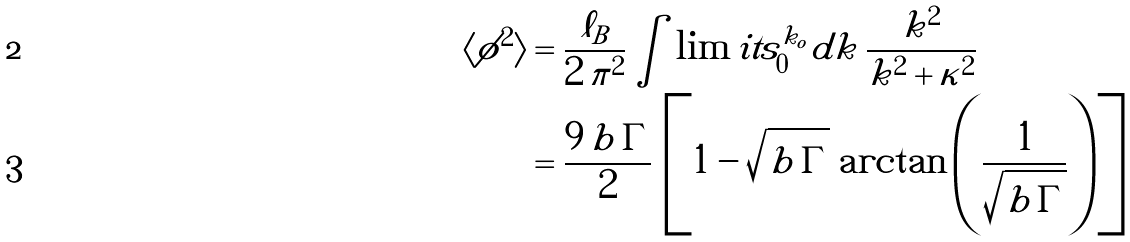<formula> <loc_0><loc_0><loc_500><loc_500>\langle \phi ^ { 2 } \rangle & = \frac { \ell _ { B } } { 2 \, \pi ^ { 2 } } \int \lim i t s _ { 0 } ^ { k _ { o } } d k \, \frac { k ^ { 2 } } { k ^ { 2 } + \kappa ^ { 2 } } \\ & = \frac { 9 \, b \, \Gamma } { 2 } \, \left [ 1 - \sqrt { b \, \Gamma } \, \arctan \left ( \frac { 1 } { \sqrt { b \, \Gamma } } \right ) \right ]</formula> 